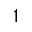<formula> <loc_0><loc_0><loc_500><loc_500>^ { 1 }</formula> 